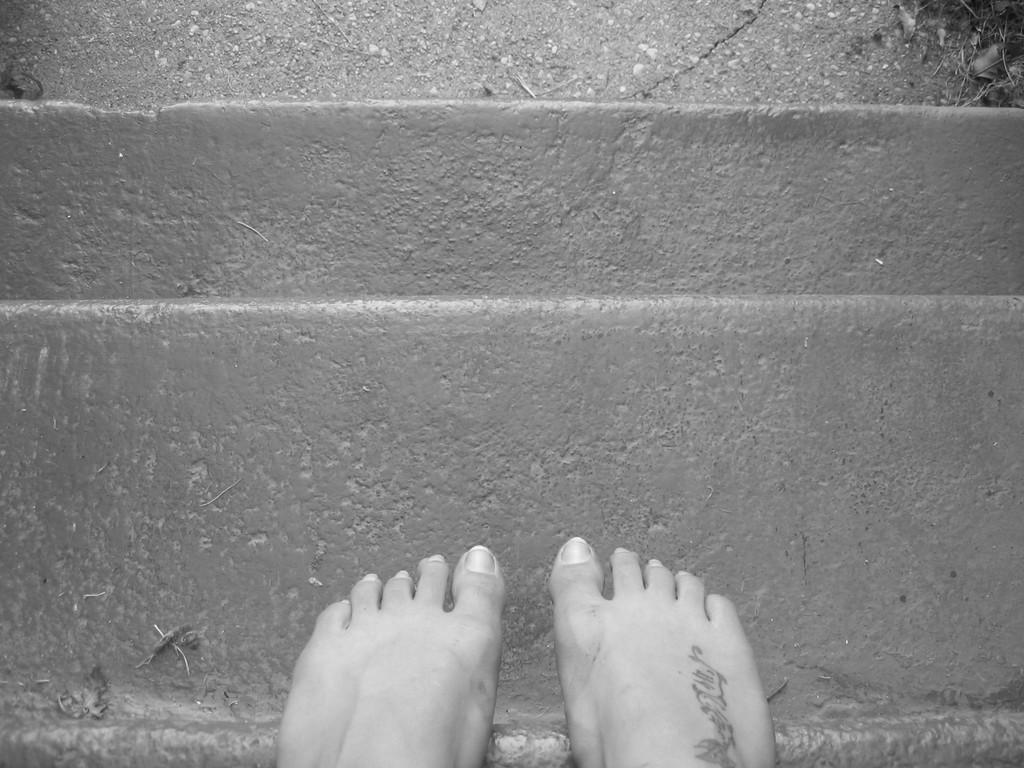What is the color scheme of the image? The image is black and white. What part of a person can be seen in the image? There is a person's foot in the image. Is there any text or writing in the image? Yes, something is written on the foot. What architectural feature is present in the image? There are steps in the image. What type of vase is placed on the steps in the image? There is no vase present in the image; it only features a person's foot and some writing on it, along with steps. What is the income of the person whose foot is in the image? There is no information about the person's income in the image, as it only shows their foot and some writing on it. 